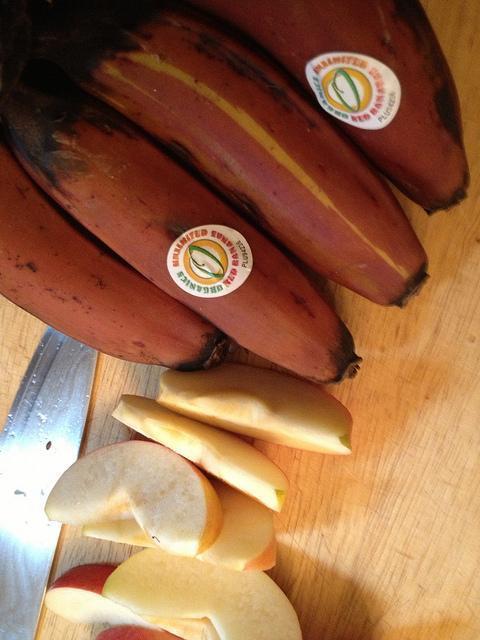Is this affirmation: "The dining table is touching the banana." correct?
Answer yes or no. Yes. 